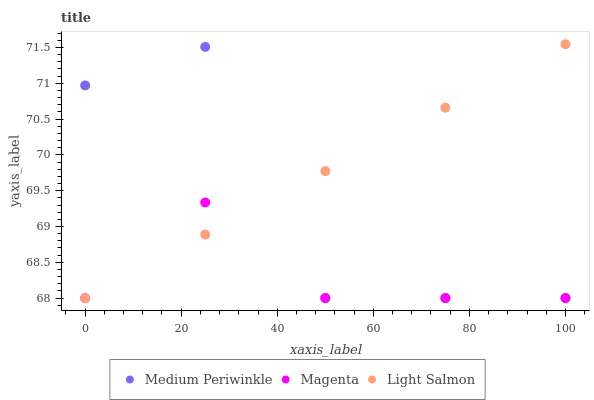Does Magenta have the minimum area under the curve?
Answer yes or no. Yes. Does Light Salmon have the maximum area under the curve?
Answer yes or no. Yes. Does Medium Periwinkle have the minimum area under the curve?
Answer yes or no. No. Does Medium Periwinkle have the maximum area under the curve?
Answer yes or no. No. Is Light Salmon the smoothest?
Answer yes or no. Yes. Is Medium Periwinkle the roughest?
Answer yes or no. Yes. Is Medium Periwinkle the smoothest?
Answer yes or no. No. Is Light Salmon the roughest?
Answer yes or no. No. Does Magenta have the lowest value?
Answer yes or no. Yes. Does Light Salmon have the highest value?
Answer yes or no. Yes. Does Medium Periwinkle have the highest value?
Answer yes or no. No. Does Medium Periwinkle intersect Magenta?
Answer yes or no. Yes. Is Medium Periwinkle less than Magenta?
Answer yes or no. No. Is Medium Periwinkle greater than Magenta?
Answer yes or no. No. 